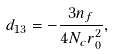Convert formula to latex. <formula><loc_0><loc_0><loc_500><loc_500>d _ { 1 3 } = - \frac { 3 n _ { f } } { 4 N _ { c } r _ { 0 } ^ { 2 } } ,</formula> 